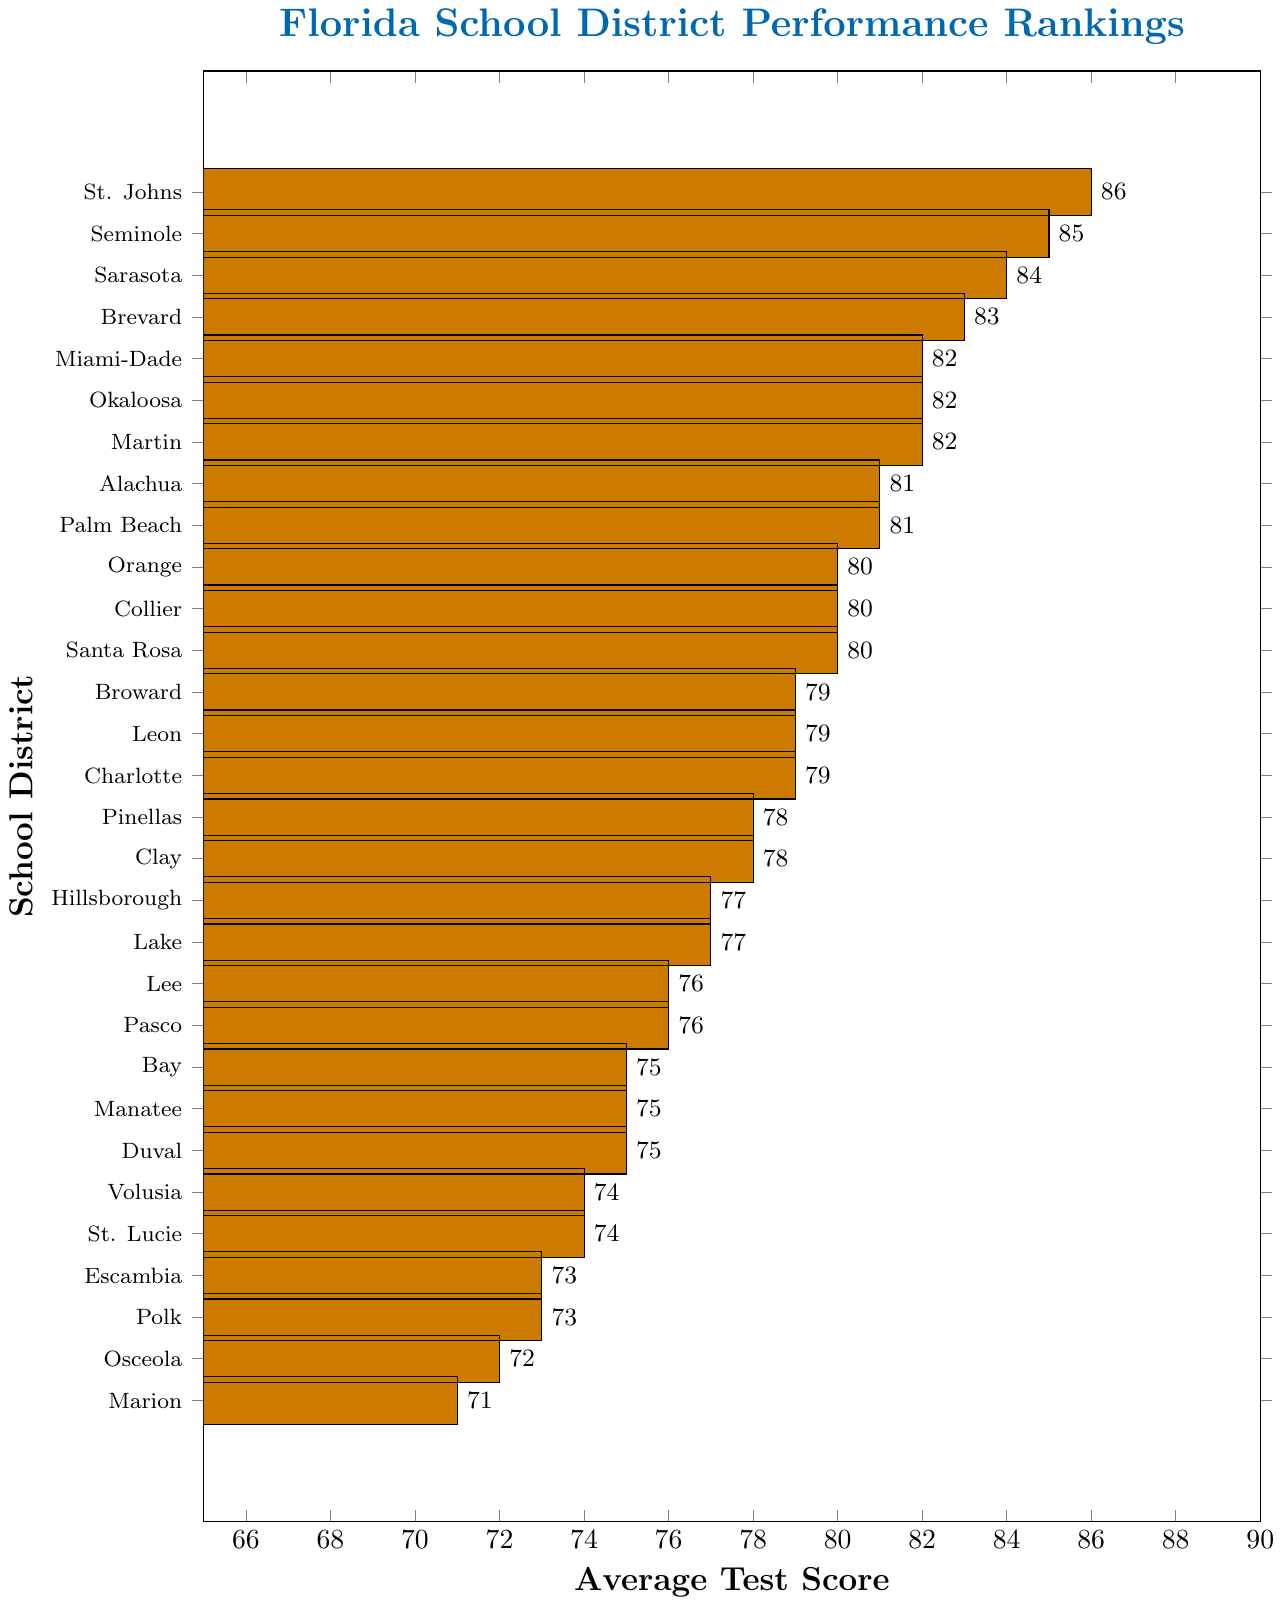what is the highest average test score among the districts? The highest value on the x-axis corresponds to the St. Johns district, which is positioned at the top with a score of 86.
Answer: 86 which district has the lowest average test score? The lowest value on the x-axis is 71, which corresponds to the Marion district at the bottom of the chart.
Answer: Marion compare the average test scores of Seminole and Sarasota districts Seminole has an average test score of 85, whereas Sarasota has an average test score of 84.
Answer: Seminole > Sarasota how many districts have an average test score above 80? To find the number of districts with scores above 80, count the bars with values greater than 80: St. Johns, Seminole, Sarasota, Brevard, Miami-Dade, Okaloosa, Martin, Alachua, Palm Beach, Orange, Collier, and Santa Rosa.
Answer: 12 what is the combined average test score of Miami-Dade and Broward districts? Miami-Dade has a score of 82 and Broward has a score of 79. Add these scores together: 82 + 79.
Answer: 161 which districts have the same average test score? By examining the bars, districts with the same scores include: Okaloosa, Martin, and Miami-Dade (82), Alachua and Palm Beach (81), Santa Rosa, Collier, and Orange (80), Leon and Charlotte (79), Pasco and Lee (76), Bay, Manatee, and Duval (75), Volusia and St. Lucie (74), and Escambia and Polk (73).
Answer: Multiple districts what is the difference between the highest and lowest average test scores? The highest score is 86 (St. Johns) and the lowest score is 71 (Marion). Subtract the lowest score from the highest: 86 - 71.
Answer: 15 which three districts have the closest average test scores? Okaloosa, Martin, and Miami-Dade each have an average test score of 82, which is the smallest range among the data points.
Answer: Okaloosa, Martin, Miami-Dade what color are the bars representing the districts? The bars are all in a shade of orange.
Answer: orange 